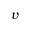Convert formula to latex. <formula><loc_0><loc_0><loc_500><loc_500>v</formula> 